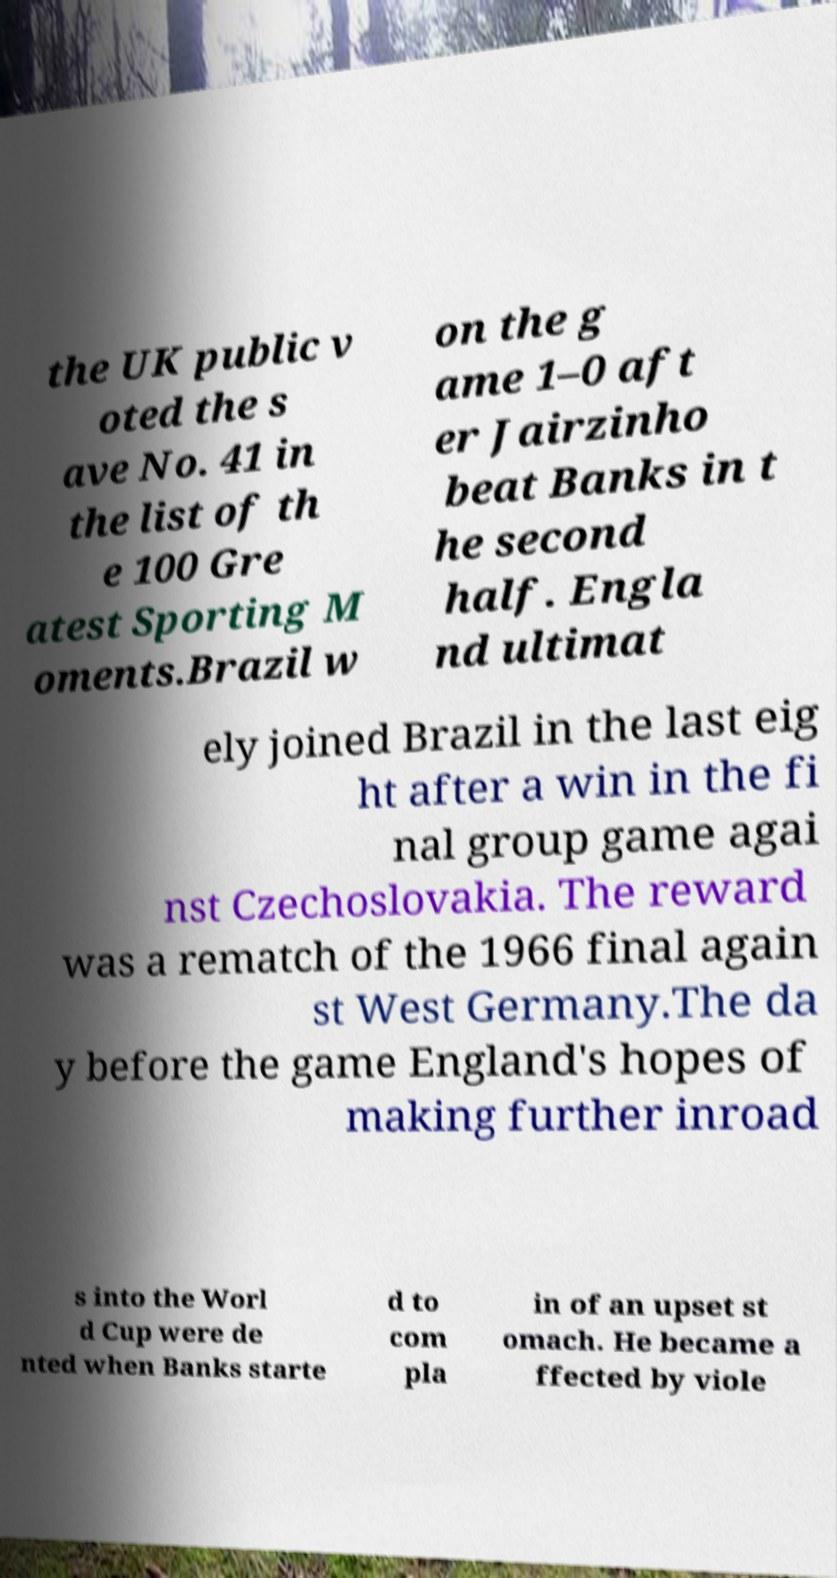Please identify and transcribe the text found in this image. the UK public v oted the s ave No. 41 in the list of th e 100 Gre atest Sporting M oments.Brazil w on the g ame 1–0 aft er Jairzinho beat Banks in t he second half. Engla nd ultimat ely joined Brazil in the last eig ht after a win in the fi nal group game agai nst Czechoslovakia. The reward was a rematch of the 1966 final again st West Germany.The da y before the game England's hopes of making further inroad s into the Worl d Cup were de nted when Banks starte d to com pla in of an upset st omach. He became a ffected by viole 